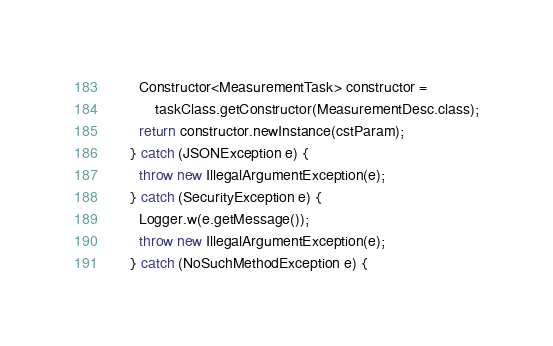<code> <loc_0><loc_0><loc_500><loc_500><_Java_>      Constructor<MeasurementTask> constructor = 
          taskClass.getConstructor(MeasurementDesc.class);
      return constructor.newInstance(cstParam);
    } catch (JSONException e) {
      throw new IllegalArgumentException(e);
    } catch (SecurityException e) {
      Logger.w(e.getMessage());
      throw new IllegalArgumentException(e);
    } catch (NoSuchMethodException e) {</code> 